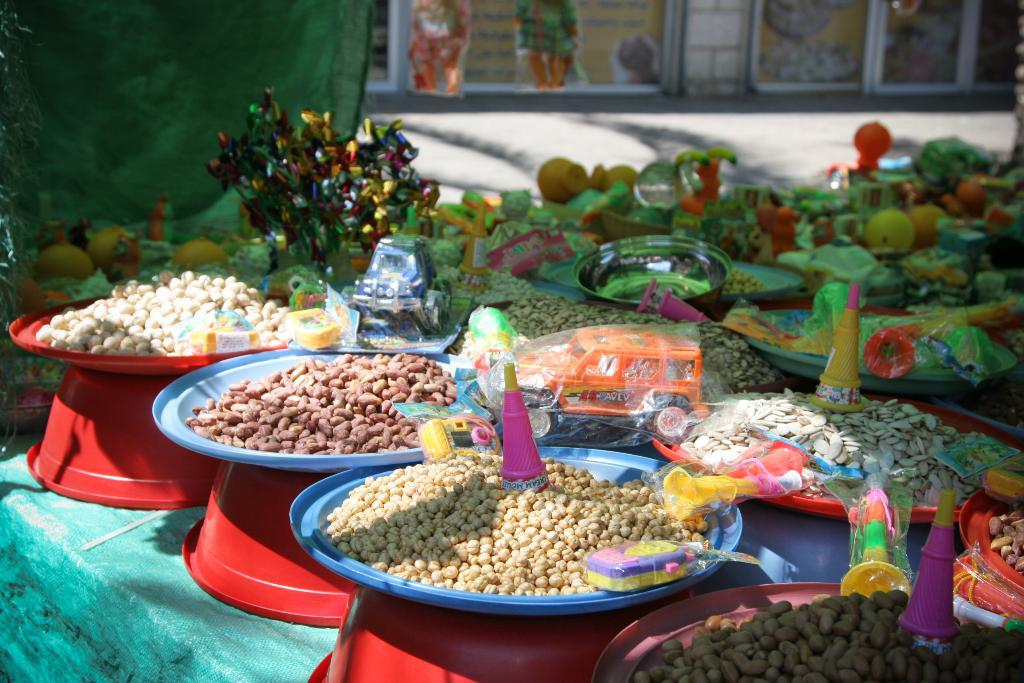What can be seen in the image related to food? There are different types of food items in the image. What else is present in the image besides food? There are toys in the image. Are there any ants crawling on the food in the image? There is no indication of ants in the image; it only shows different types of food items and toys. What is the purpose of the protest in the image? There is no protest present in the image; it only features food items and toys. 